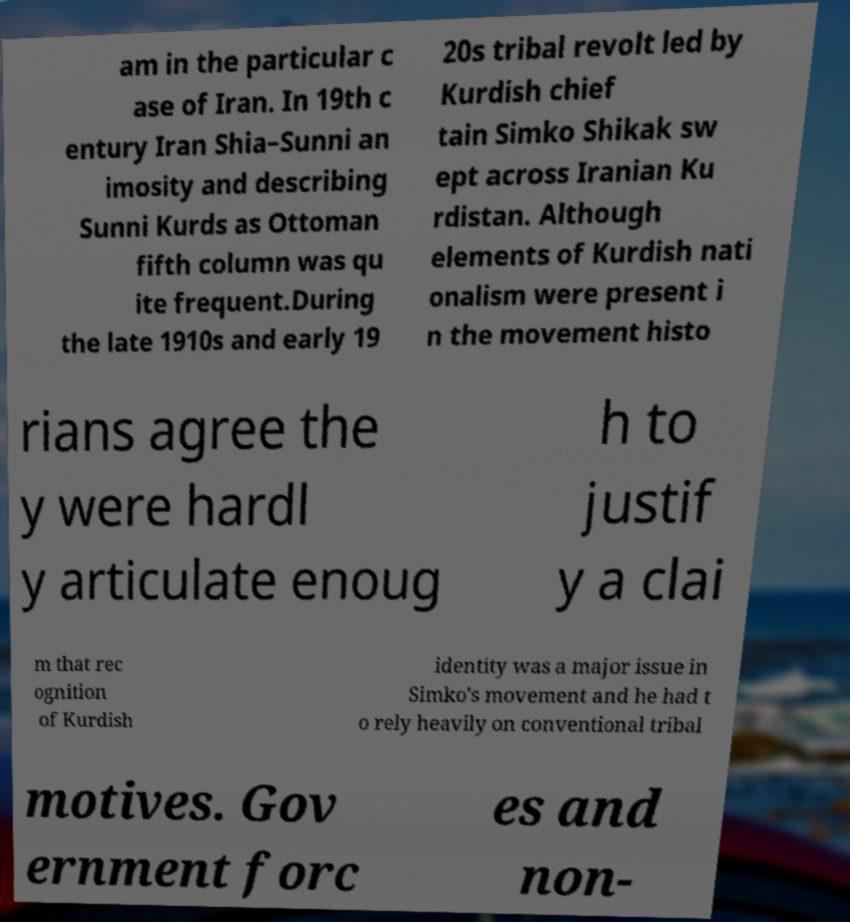There's text embedded in this image that I need extracted. Can you transcribe it verbatim? am in the particular c ase of Iran. In 19th c entury Iran Shia–Sunni an imosity and describing Sunni Kurds as Ottoman fifth column was qu ite frequent.During the late 1910s and early 19 20s tribal revolt led by Kurdish chief tain Simko Shikak sw ept across Iranian Ku rdistan. Although elements of Kurdish nati onalism were present i n the movement histo rians agree the y were hardl y articulate enoug h to justif y a clai m that rec ognition of Kurdish identity was a major issue in Simko's movement and he had t o rely heavily on conventional tribal motives. Gov ernment forc es and non- 